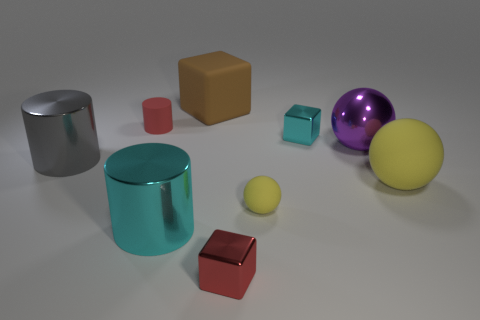How many gray things are either big matte objects or big matte cubes?
Provide a succinct answer. 0. There is a big thing that is on the left side of the large cyan metal object; does it have the same shape as the big cyan metal object?
Your response must be concise. Yes. Is the number of small red metallic objects in front of the big purple shiny sphere greater than the number of big purple rubber spheres?
Your answer should be very brief. Yes. What number of other spheres have the same size as the purple metallic sphere?
Provide a succinct answer. 1. What is the size of the block that is the same color as the matte cylinder?
Ensure brevity in your answer.  Small. What number of objects are either shiny objects or small shiny cubes behind the gray thing?
Offer a terse response. 5. The large metallic object that is both behind the large cyan thing and right of the red matte cylinder is what color?
Your response must be concise. Purple. Is the brown cube the same size as the gray metallic thing?
Ensure brevity in your answer.  Yes. There is a big rubber object that is in front of the large rubber block; what color is it?
Offer a terse response. Yellow. Are there any other matte balls of the same color as the small ball?
Keep it short and to the point. Yes. 